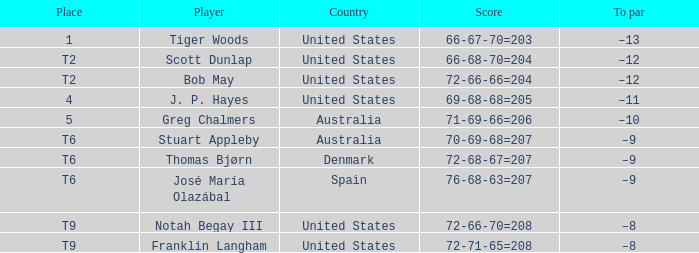Would you be able to parse every entry in this table? {'header': ['Place', 'Player', 'Country', 'Score', 'To par'], 'rows': [['1', 'Tiger Woods', 'United States', '66-67-70=203', '–13'], ['T2', 'Scott Dunlap', 'United States', '66-68-70=204', '–12'], ['T2', 'Bob May', 'United States', '72-66-66=204', '–12'], ['4', 'J. P. Hayes', 'United States', '69-68-68=205', '–11'], ['5', 'Greg Chalmers', 'Australia', '71-69-66=206', '–10'], ['T6', 'Stuart Appleby', 'Australia', '70-69-68=207', '–9'], ['T6', 'Thomas Bjørn', 'Denmark', '72-68-67=207', '–9'], ['T6', 'José María Olazábal', 'Spain', '76-68-63=207', '–9'], ['T9', 'Notah Begay III', 'United States', '72-66-70=208', '–8'], ['T9', 'Franklin Langham', 'United States', '72-71-65=208', '–8']]} What is the place of the player with a 66-68-70=204 score? T2. 